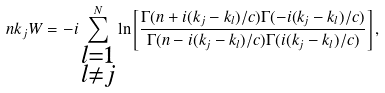Convert formula to latex. <formula><loc_0><loc_0><loc_500><loc_500>n k _ { j } W = - i \sum _ { \substack { l = 1 \\ l \neq j } } ^ { N } \ln \left [ \frac { \Gamma ( n + i ( k _ { j } - k _ { l } ) / c ) \Gamma ( - i ( k _ { j } - k _ { l } ) / c ) } { \Gamma ( n - i ( k _ { j } - k _ { l } ) / c ) \Gamma ( i ( k _ { j } - k _ { l } ) / c ) } \right ] ,</formula> 